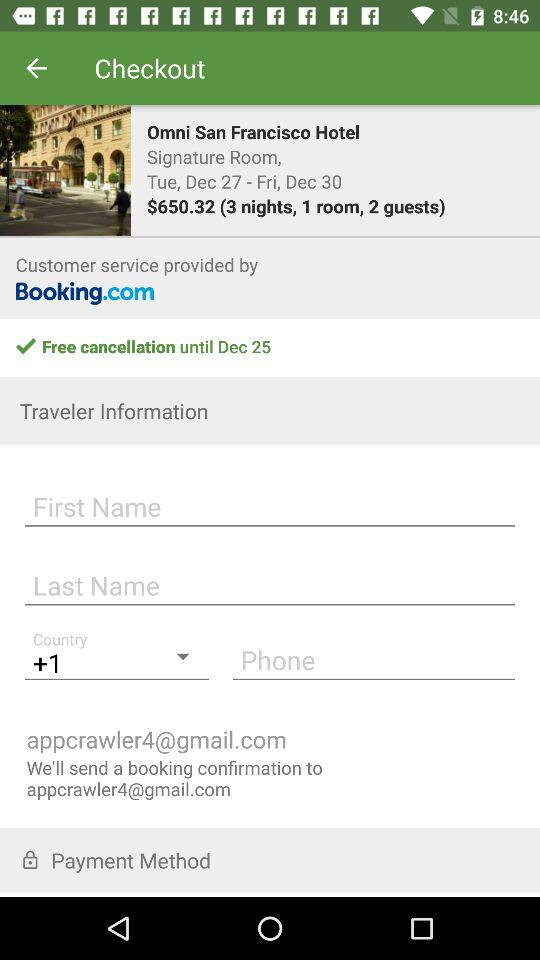What are the check-in and check-out dates? The check-in date is Tuesday, December 27 and the check-out date is Friday, December 30. 